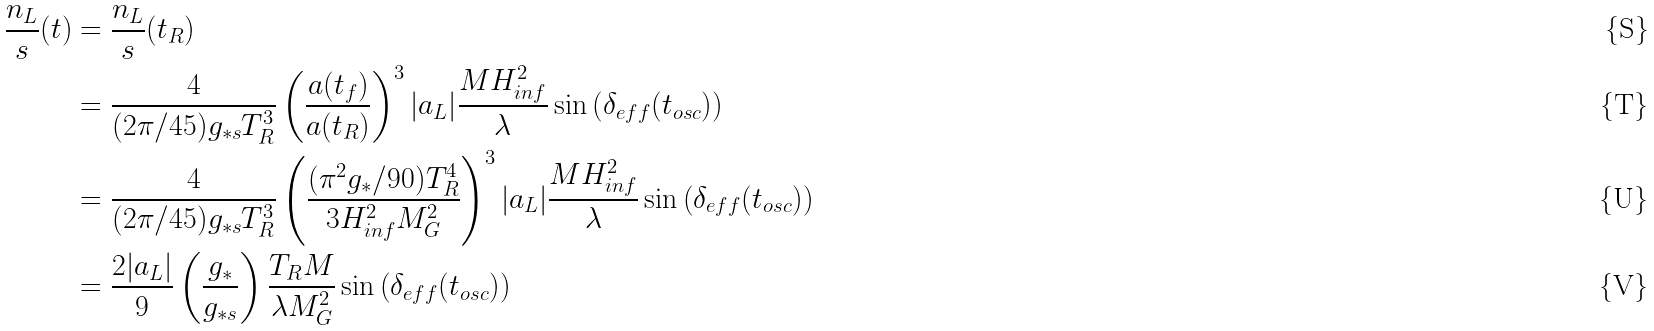Convert formula to latex. <formula><loc_0><loc_0><loc_500><loc_500>\frac { n _ { L } } { s } ( t ) & = \frac { n _ { L } } { s } ( t _ { R } ) \\ & = \frac { 4 } { ( 2 \pi / 4 5 ) g _ { * s } T _ { R } ^ { 3 } } \left ( \frac { a ( t _ { f } ) } { a ( t _ { R } ) } \right ) ^ { 3 } | a _ { L } | \frac { M H _ { i n f } ^ { 2 } } { \lambda } \sin \left ( \delta _ { e f f } ( t _ { o s c } ) \right ) \\ & = \frac { 4 } { ( 2 \pi / 4 5 ) g _ { * s } T _ { R } ^ { 3 } } \left ( \frac { ( \pi ^ { 2 } g _ { * } / 9 0 ) T _ { R } ^ { 4 } } { 3 H _ { i n f } ^ { 2 } M _ { G } ^ { 2 } } \right ) ^ { 3 } | a _ { L } | \frac { M H _ { i n f } ^ { 2 } } { \lambda } \sin \left ( \delta _ { e f f } ( t _ { o s c } ) \right ) \\ & = \frac { 2 | a _ { L } | } { 9 } \left ( \frac { g _ { * } } { g _ { * s } } \right ) \frac { T _ { R } M } { \lambda M _ { G } ^ { 2 } } \sin \left ( \delta _ { e f f } ( t _ { o s c } ) \right )</formula> 